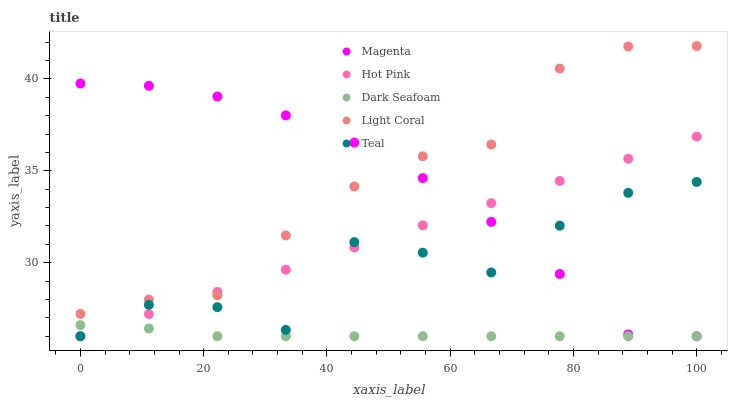Does Dark Seafoam have the minimum area under the curve?
Answer yes or no. Yes. Does Light Coral have the maximum area under the curve?
Answer yes or no. Yes. Does Magenta have the minimum area under the curve?
Answer yes or no. No. Does Magenta have the maximum area under the curve?
Answer yes or no. No. Is Hot Pink the smoothest?
Answer yes or no. Yes. Is Teal the roughest?
Answer yes or no. Yes. Is Magenta the smoothest?
Answer yes or no. No. Is Magenta the roughest?
Answer yes or no. No. Does Magenta have the lowest value?
Answer yes or no. Yes. Does Light Coral have the highest value?
Answer yes or no. Yes. Does Magenta have the highest value?
Answer yes or no. No. Is Teal less than Light Coral?
Answer yes or no. Yes. Is Light Coral greater than Dark Seafoam?
Answer yes or no. Yes. Does Hot Pink intersect Magenta?
Answer yes or no. Yes. Is Hot Pink less than Magenta?
Answer yes or no. No. Is Hot Pink greater than Magenta?
Answer yes or no. No. Does Teal intersect Light Coral?
Answer yes or no. No. 